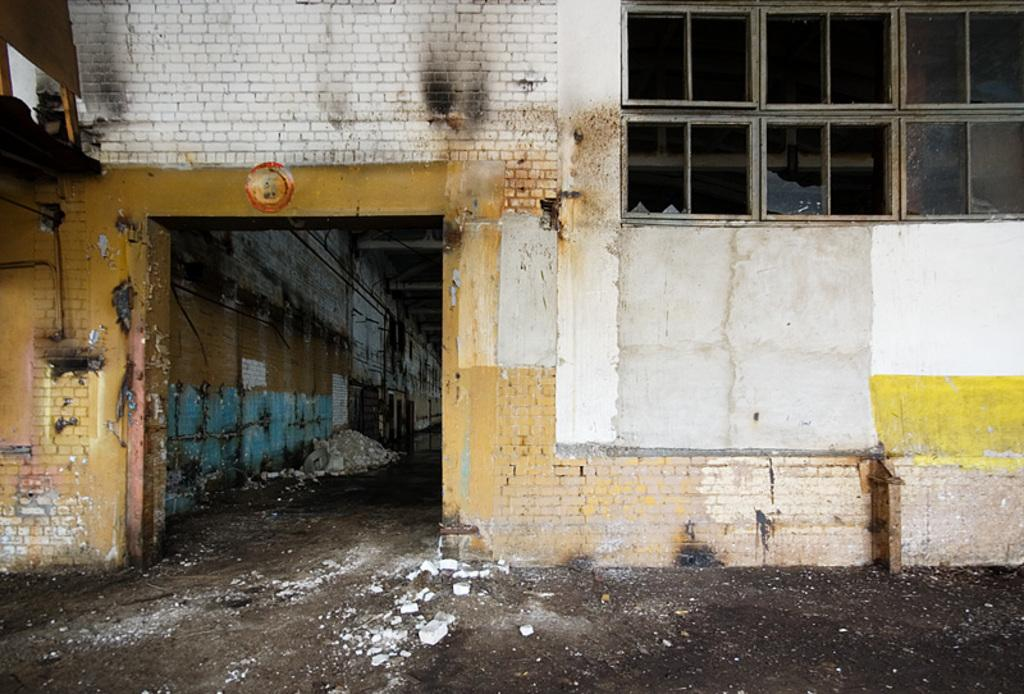What type of structure is visible in the image? There is a building in the image. What objects can be seen on the ground in the image? There are broken glasses and broken bricks on the ground in the image. What architectural features are present in the image? There are windows and poles in the image. What type of metal can be seen in the lace pattern on the building? There is no lace pattern or metal visible on the building in the image. 